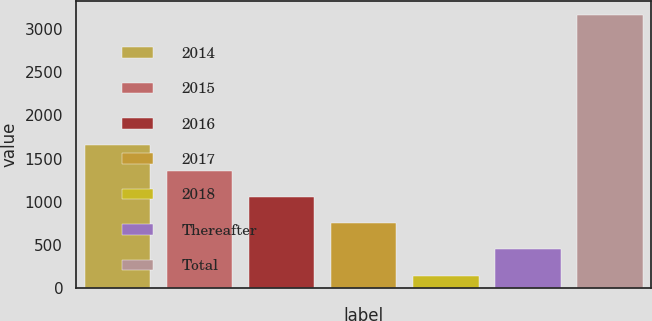Convert chart. <chart><loc_0><loc_0><loc_500><loc_500><bar_chart><fcel>2014<fcel>2015<fcel>2016<fcel>2017<fcel>2018<fcel>Thereafter<fcel>Total<nl><fcel>1655.5<fcel>1353.4<fcel>1051.3<fcel>749.2<fcel>145<fcel>447.1<fcel>3166<nl></chart> 